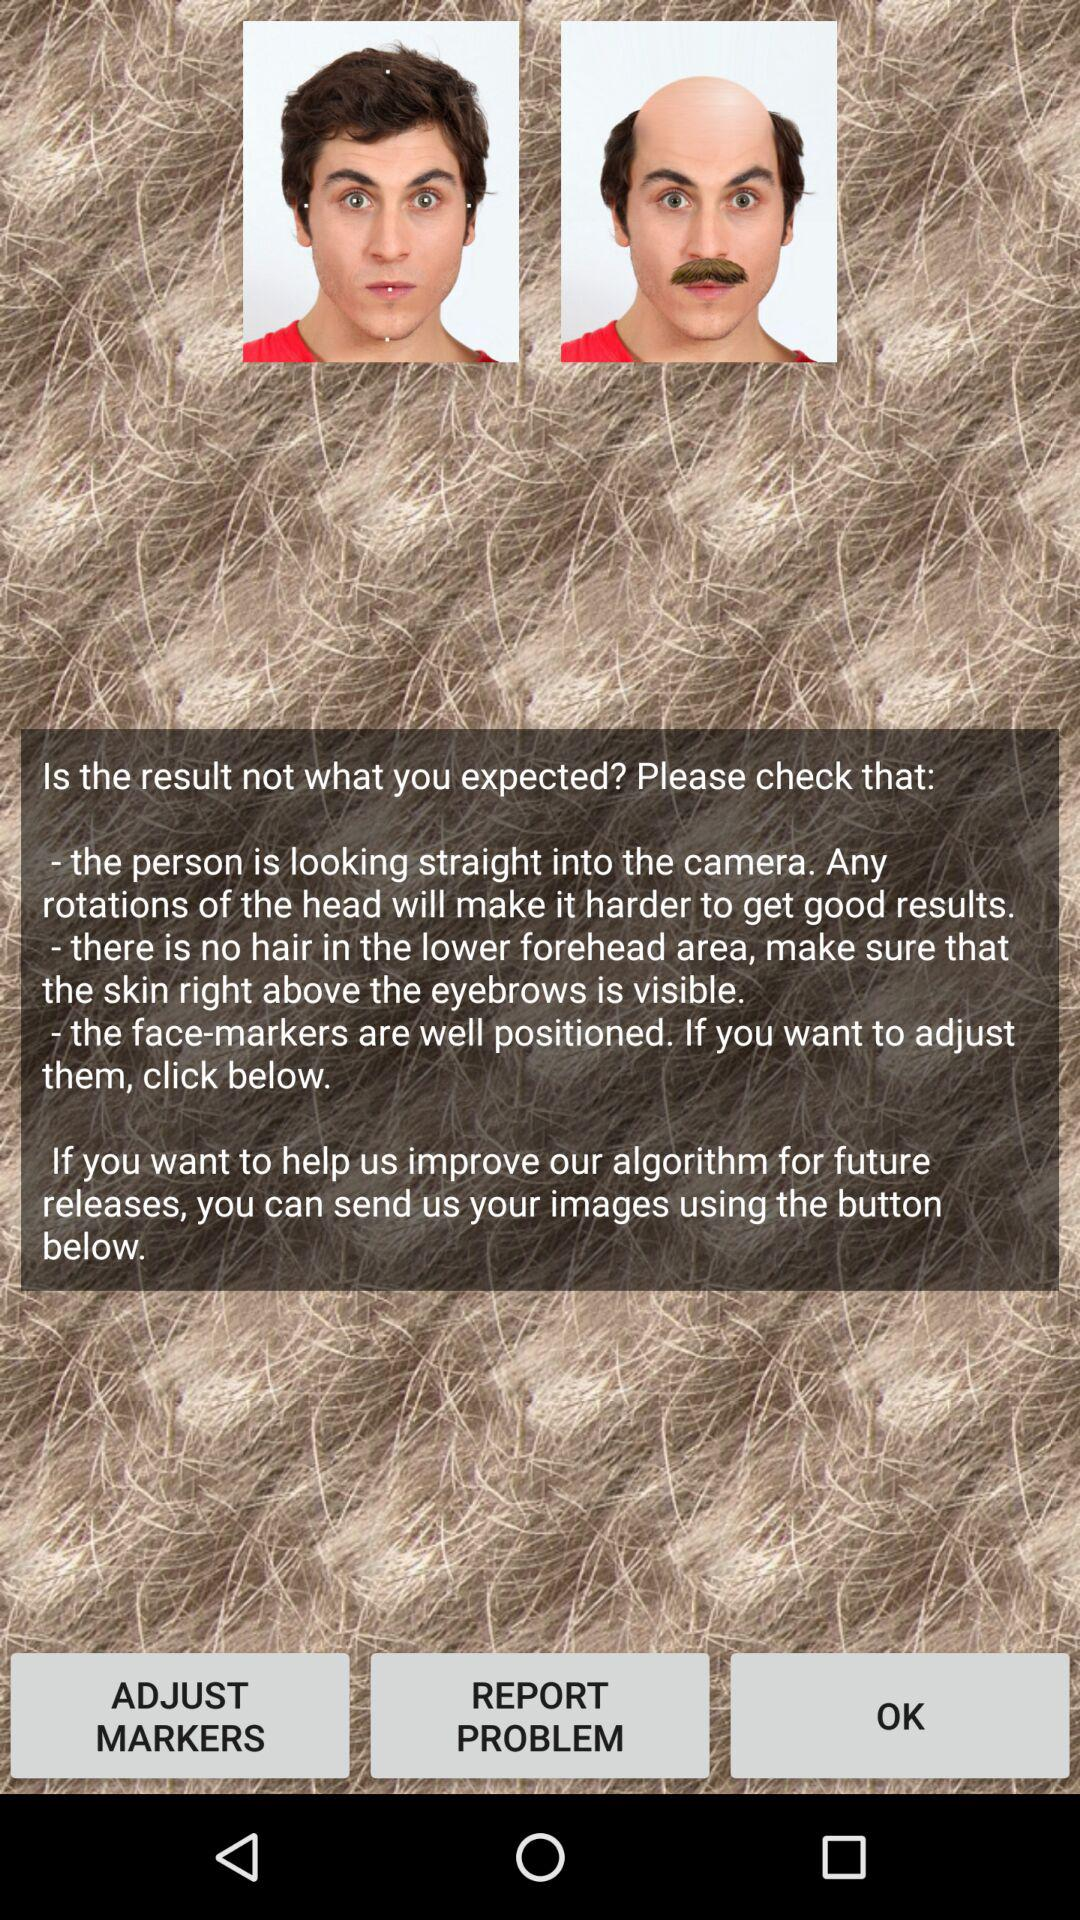Where is the person looking? The person is looking straight into the camera. 